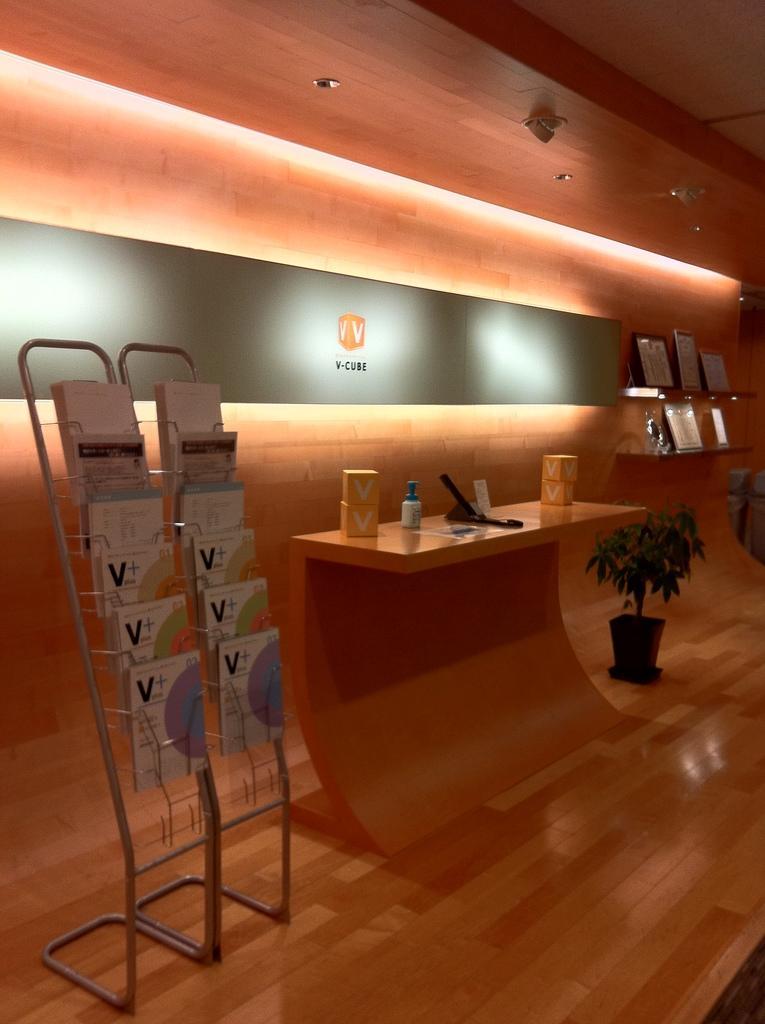In one or two sentences, can you explain what this image depicts? In this picture I see the stand on which there are few books and I see the desk side to the stand on which there are few things and I see a plant on the floor. In the background I see the wall and I see the lights and I see few more things over here. 